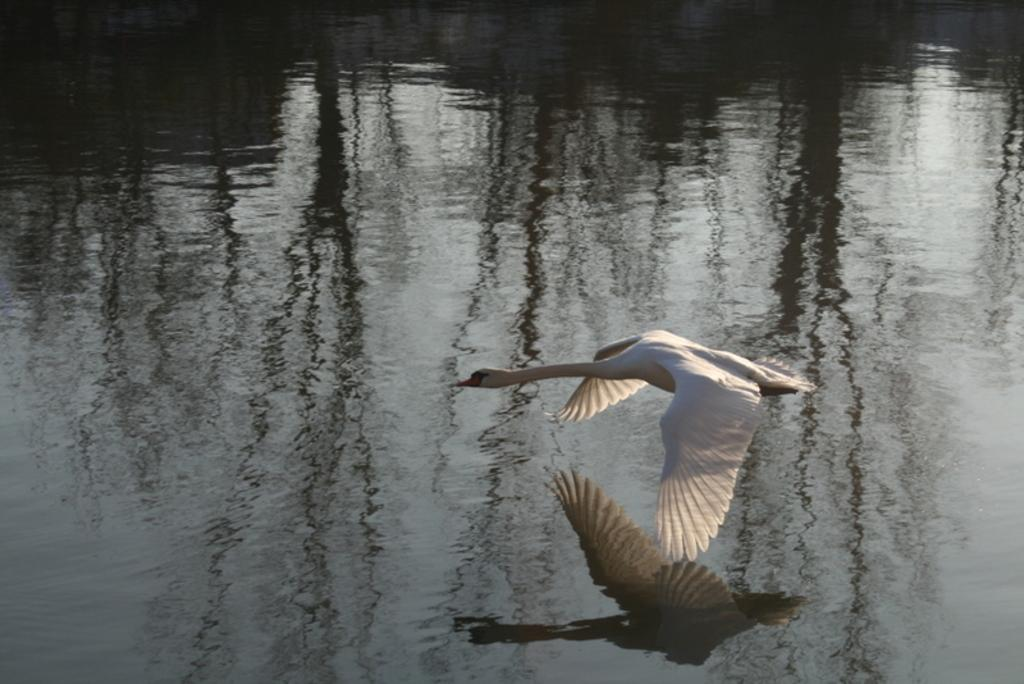What type of animal can be seen in the image? There is a bird in the image. What is the bird doing in the image? The bird is flying in the air. What can be seen in the background of the image? There is water visible in the background of the image. What type of juice is the bird drinking in the image? There is no juice present in the image; the bird is flying in the air. 